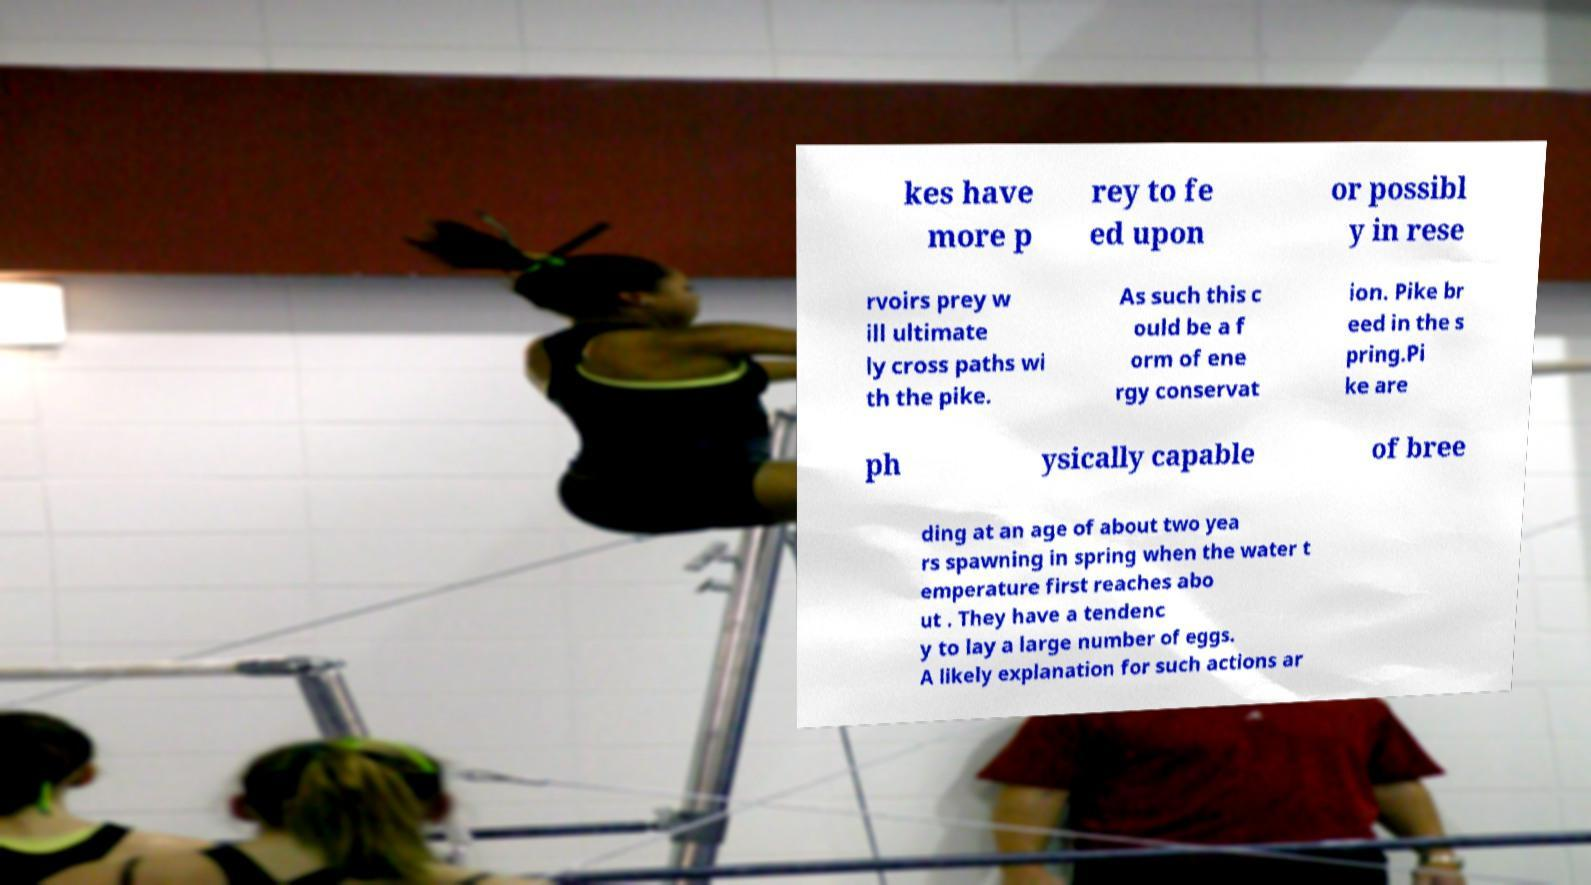I need the written content from this picture converted into text. Can you do that? kes have more p rey to fe ed upon or possibl y in rese rvoirs prey w ill ultimate ly cross paths wi th the pike. As such this c ould be a f orm of ene rgy conservat ion. Pike br eed in the s pring.Pi ke are ph ysically capable of bree ding at an age of about two yea rs spawning in spring when the water t emperature first reaches abo ut . They have a tendenc y to lay a large number of eggs. A likely explanation for such actions ar 